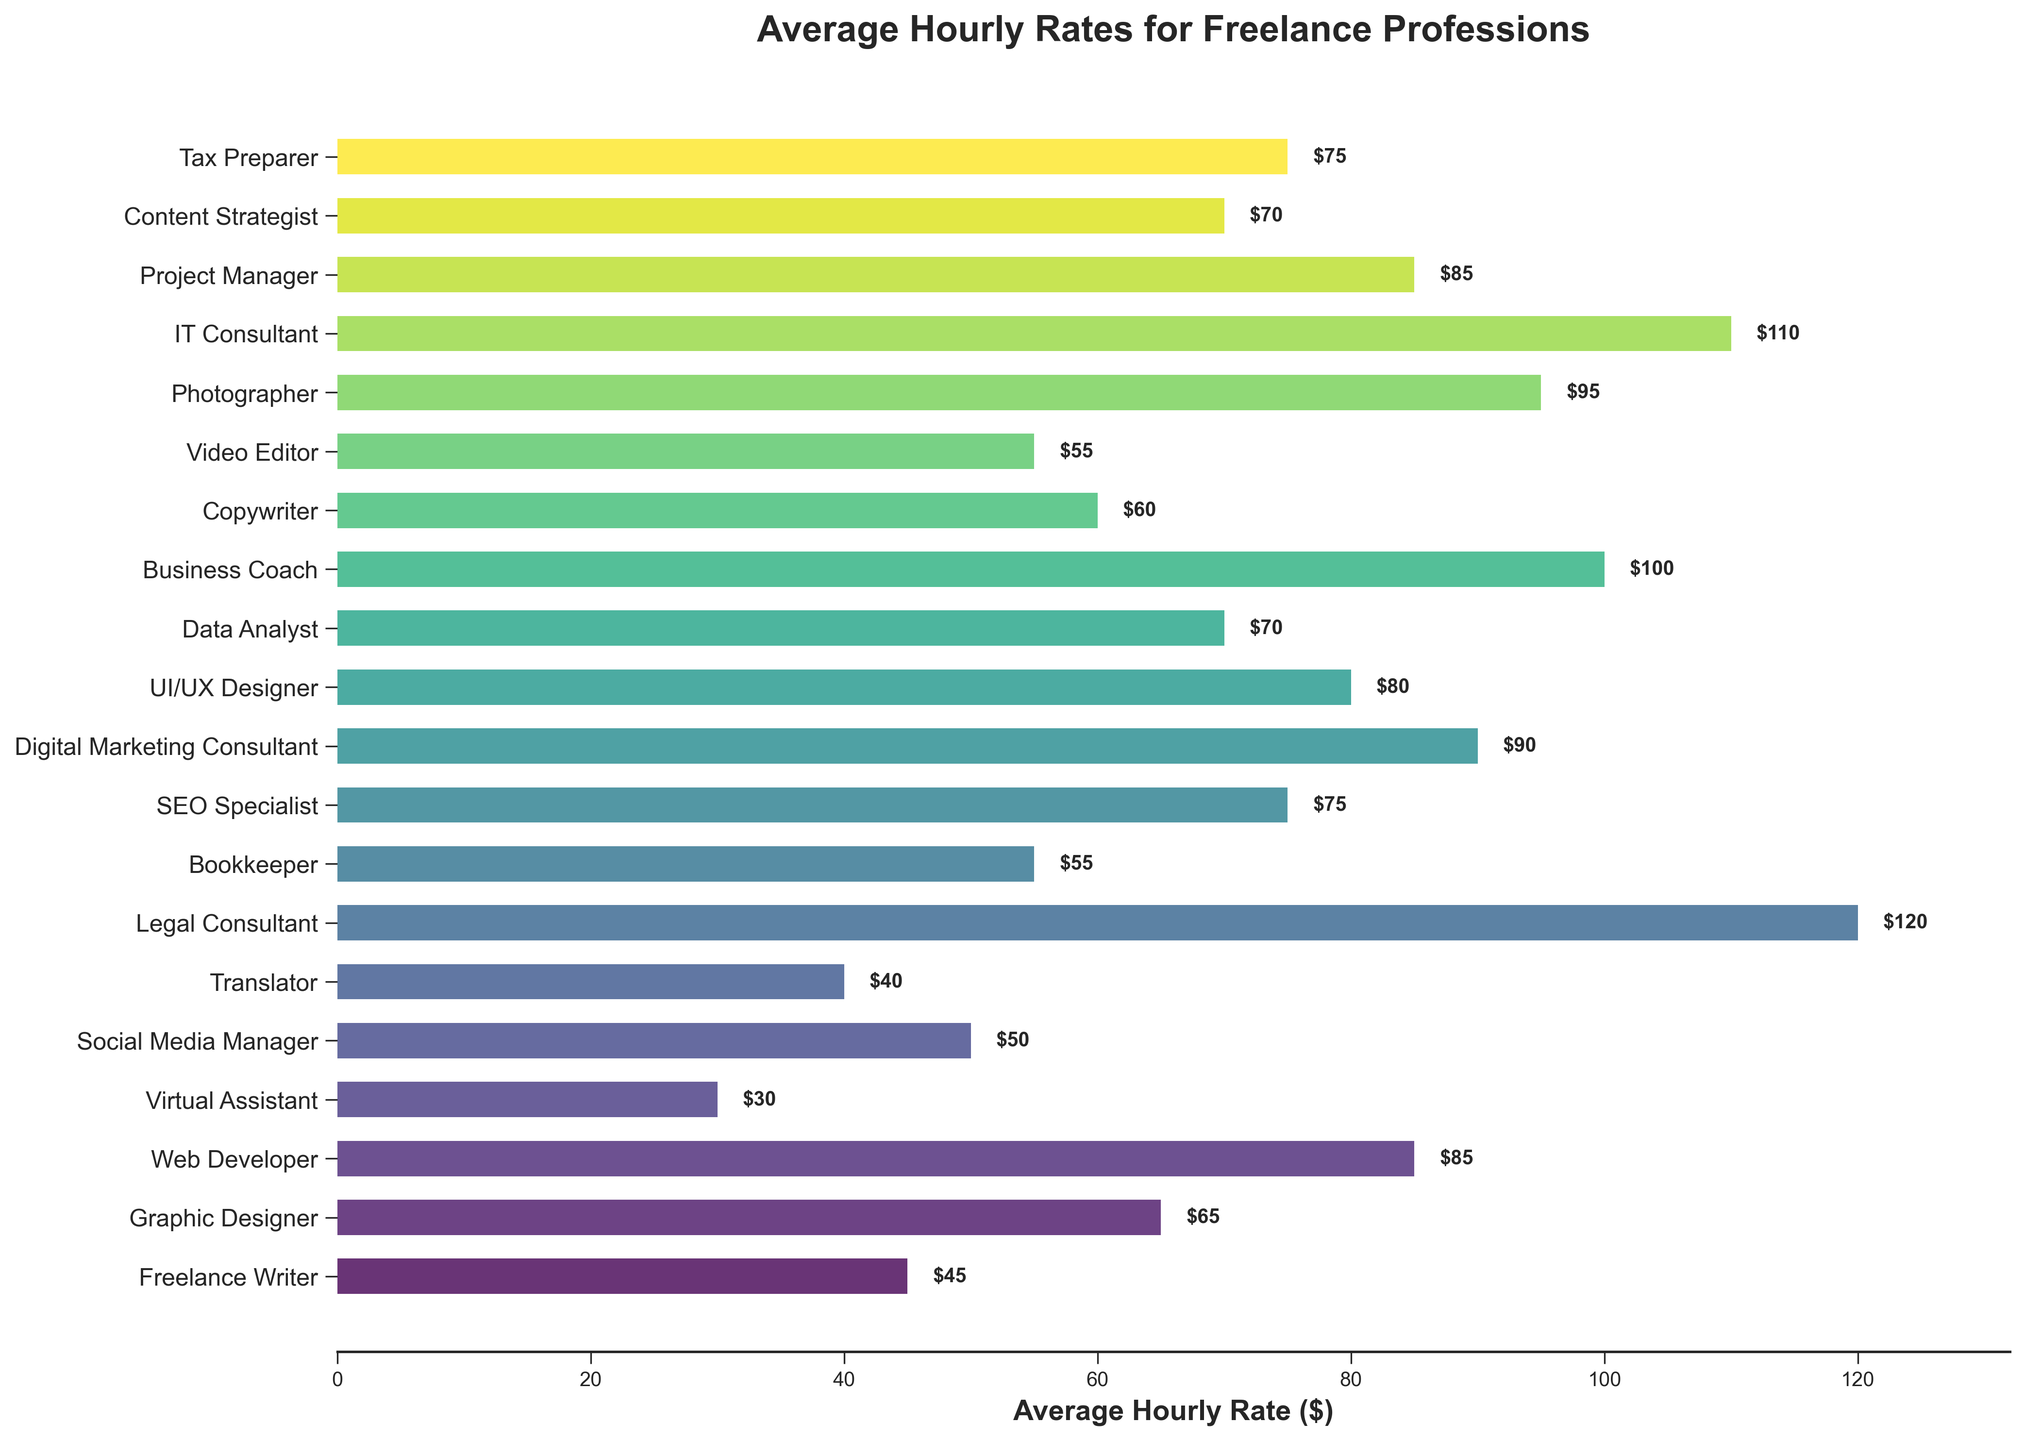Which profession has the highest average hourly rate? The profession with the highest average hourly rate can be found by identifying the tallest bar on the chart. The tallest bar represents the Legal Consultant with an hourly rate of $120.
Answer: Legal Consultant Which two professions have the same average hourly rate? To find professions with the same average hourly rate, we look for bars with the same length. Video Editor and Bookkeeper both have an hourly rate of $55.
Answer: Video Editor and Bookkeeper What is the difference in average hourly rate between Web Developer and Virtual Assistant? The Web Developer has an average hourly rate of $85, and the Virtual Assistant has an average hourly rate of $30. The difference is $85 - $30 = $55.
Answer: $55 What is the combined average hourly rate of the top three highest-paid professions? The three highest-paid professions are Legal Consultant ($120), IT Consultant ($110), and Business Coach ($100). Their combined rate is $120 + $110 + $100 = $330.
Answer: $330 What is the average hourly rate for Graphic Designer, Copywriter, and SEO Specialist? The hourly rates are Graphic Designer ($65), Copywriter ($60), and SEO Specialist ($75). The average is calculated as ($65 + $60 + $75) / 3 = $66.67.
Answer: $66.67 Which profession has a higher average hourly rate: Social Media Manager or Translator? The Social Media Manager has an average hourly rate of $50, while the Translator has an hourly rate of $40. $50 is greater than $40, so the Social Media Manager has a higher rate.
Answer: Social Media Manager How much more does a Photographer earn per hour compared to a Data Analyst? The average hourly rate for a Photographer is $95, and for a Data Analyst, it is $70. The Photographer earns $95 - $70 = $25 more per hour.
Answer: $25 Which profession ranks just above the Project Manager in terms of average hourly rate? The Project Manager has an hourly rate of $85. The Digital Marketing Consultant has an hourly rate of $90, which is just above $85.
Answer: Digital Marketing Consultant Is the average hourly rate for a Virtual Assistant less than half that of a Legal Consultant? The average hourly rate for Virtual Assistant is $30, and for Legal Consultant is $120. Half of $120 is $60, and $30 is less than $60.
Answer: Yes What is the average hourly rate for professions that have rates above $80? The professions with rates above $80 are Web Developer ($85), Digital Marketing Consultant ($90), UI/UX Designer ($80), Photographer ($95), IT Consultant ($110), Project Manager ($85), Legal Consultant ($120), Business Coach ($100). The average is ($85+$90+$80+$95+$110+$85+$120+$100) / 8 = $95.63.
Answer: $95.63 